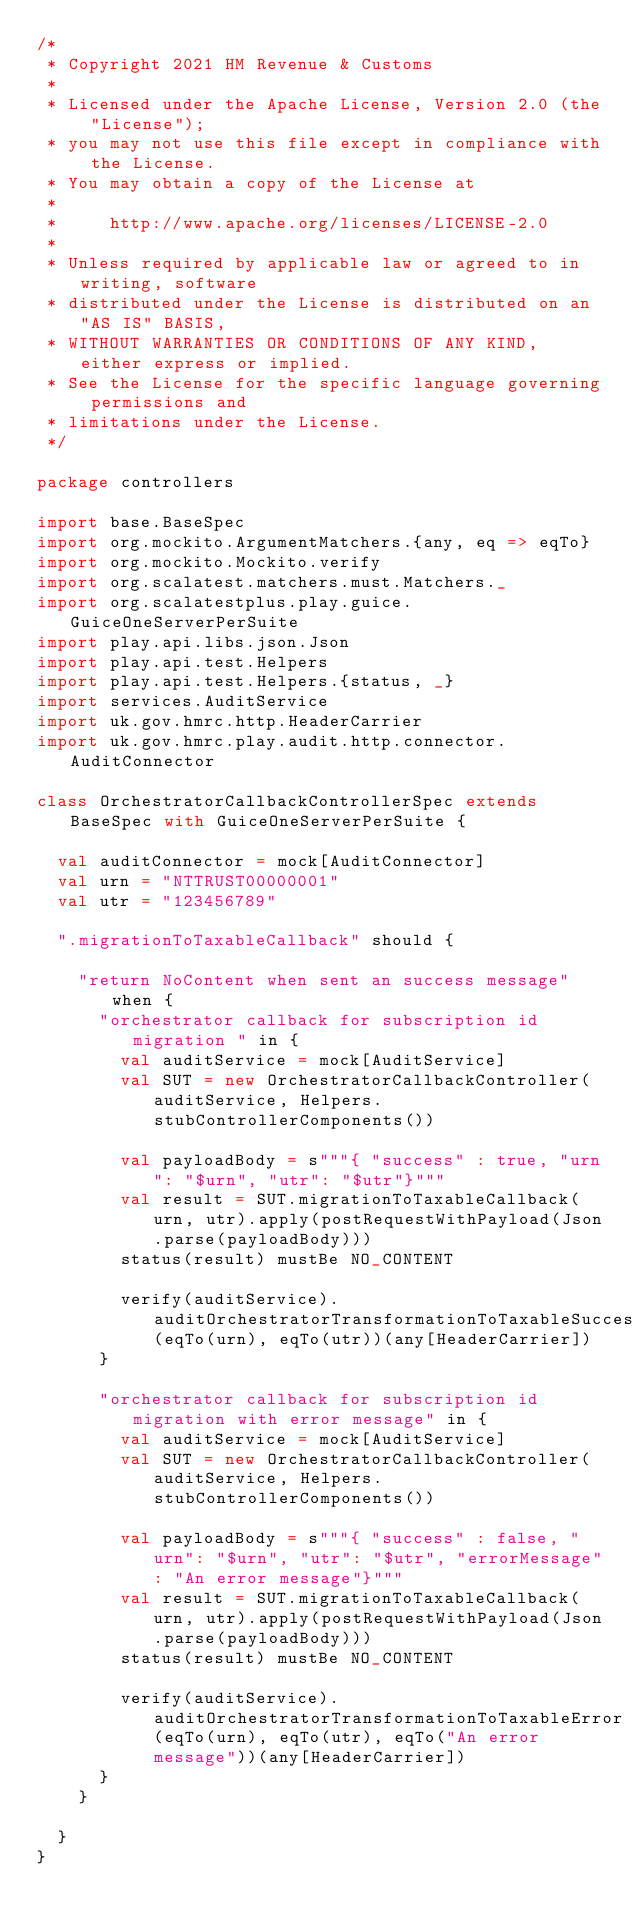Convert code to text. <code><loc_0><loc_0><loc_500><loc_500><_Scala_>/*
 * Copyright 2021 HM Revenue & Customs
 *
 * Licensed under the Apache License, Version 2.0 (the "License");
 * you may not use this file except in compliance with the License.
 * You may obtain a copy of the License at
 *
 *     http://www.apache.org/licenses/LICENSE-2.0
 *
 * Unless required by applicable law or agreed to in writing, software
 * distributed under the License is distributed on an "AS IS" BASIS,
 * WITHOUT WARRANTIES OR CONDITIONS OF ANY KIND, either express or implied.
 * See the License for the specific language governing permissions and
 * limitations under the License.
 */

package controllers

import base.BaseSpec
import org.mockito.ArgumentMatchers.{any, eq => eqTo}
import org.mockito.Mockito.verify
import org.scalatest.matchers.must.Matchers._
import org.scalatestplus.play.guice.GuiceOneServerPerSuite
import play.api.libs.json.Json
import play.api.test.Helpers
import play.api.test.Helpers.{status, _}
import services.AuditService
import uk.gov.hmrc.http.HeaderCarrier
import uk.gov.hmrc.play.audit.http.connector.AuditConnector

class OrchestratorCallbackControllerSpec extends BaseSpec with GuiceOneServerPerSuite {

  val auditConnector = mock[AuditConnector]
  val urn = "NTTRUST00000001"
  val utr = "123456789"

  ".migrationToTaxableCallback" should {

    "return NoContent when sent an success message" when {
      "orchestrator callback for subscription id migration " in {
        val auditService = mock[AuditService]
        val SUT = new OrchestratorCallbackController(auditService, Helpers.stubControllerComponents())

        val payloadBody = s"""{ "success" : true, "urn": "$urn", "utr": "$utr"}"""
        val result = SUT.migrationToTaxableCallback(urn, utr).apply(postRequestWithPayload(Json.parse(payloadBody)))
        status(result) mustBe NO_CONTENT

        verify(auditService).auditOrchestratorTransformationToTaxableSuccess(eqTo(urn), eqTo(utr))(any[HeaderCarrier])
      }

      "orchestrator callback for subscription id migration with error message" in {
        val auditService = mock[AuditService]
        val SUT = new OrchestratorCallbackController(auditService, Helpers.stubControllerComponents())

        val payloadBody = s"""{ "success" : false, "urn": "$urn", "utr": "$utr", "errorMessage": "An error message"}"""
        val result = SUT.migrationToTaxableCallback(urn, utr).apply(postRequestWithPayload(Json.parse(payloadBody)))
        status(result) mustBe NO_CONTENT

        verify(auditService).auditOrchestratorTransformationToTaxableError(eqTo(urn), eqTo(utr), eqTo("An error message"))(any[HeaderCarrier])
      }
    }

  }
}
</code> 